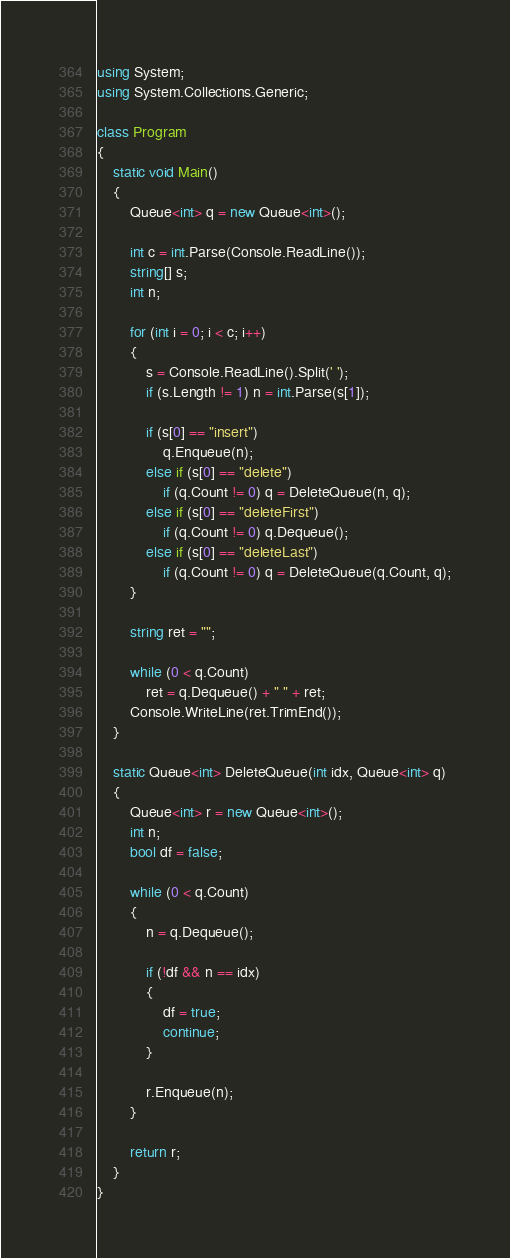Convert code to text. <code><loc_0><loc_0><loc_500><loc_500><_C#_>using System;
using System.Collections.Generic;

class Program
{
    static void Main()
    {
        Queue<int> q = new Queue<int>();

        int c = int.Parse(Console.ReadLine());
        string[] s;
        int n;

        for (int i = 0; i < c; i++)
        {
            s = Console.ReadLine().Split(' ');
            if (s.Length != 1) n = int.Parse(s[1]);

            if (s[0] == "insert")
                q.Enqueue(n);
            else if (s[0] == "delete")
                if (q.Count != 0) q = DeleteQueue(n, q);
            else if (s[0] == "deleteFirst")
                if (q.Count != 0) q.Dequeue();
            else if (s[0] == "deleteLast")
                if (q.Count != 0) q = DeleteQueue(q.Count, q);
        }

        string ret = "";

        while (0 < q.Count)
            ret = q.Dequeue() + " " + ret;
        Console.WriteLine(ret.TrimEnd());
    }

    static Queue<int> DeleteQueue(int idx, Queue<int> q)
    {
        Queue<int> r = new Queue<int>();
        int n;
        bool df = false;

        while (0 < q.Count)
        {
            n = q.Dequeue();

            if (!df && n == idx)
            {
                df = true;
                continue;
            }

            r.Enqueue(n);
        }

        return r;
    }
}
</code> 